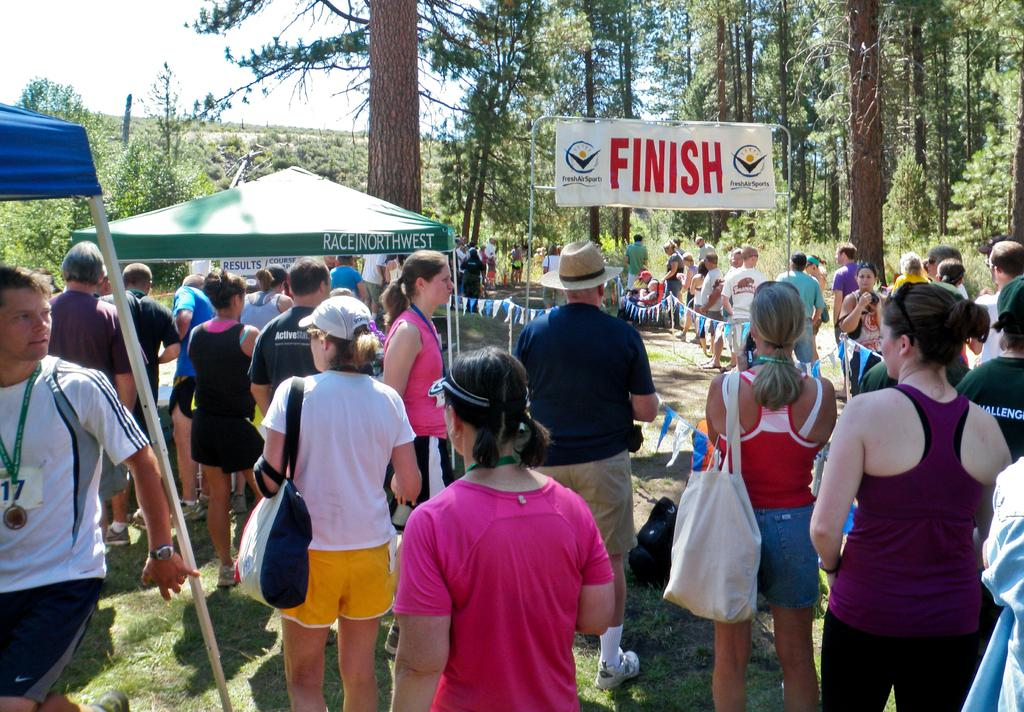Who or what can be seen in the image? There are people in the image. What structures are present in the image? There are tents and a board visible in the image. What additional elements can be seen in the image? Flags are visible in the image. What can be seen in the background of the image? There are trees and the sky visible in the background of the image. What is the mass of the expansion in the image? There is no expansion present in the image, so it is not possible to determine its mass. 